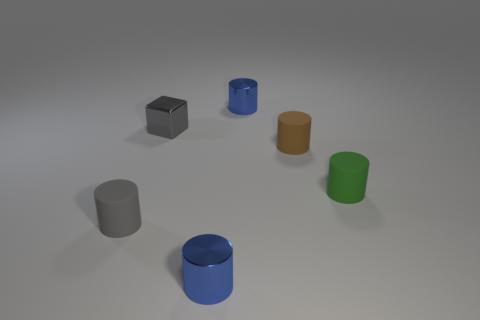Is there any other thing that has the same shape as the gray metal object?
Give a very brief answer. No. The matte cylinder that is the same color as the block is what size?
Make the answer very short. Small. What is the material of the blue cylinder that is in front of the tiny green object?
Your answer should be compact. Metal. Is the number of small metallic objects to the left of the small gray matte cylinder the same as the number of blue metallic cylinders behind the gray metal block?
Your response must be concise. No. What number of matte objects have the same color as the metallic cube?
Keep it short and to the point. 1. There is a small thing that is the same color as the shiny block; what is its material?
Offer a terse response. Rubber. Are there more tiny things that are on the left side of the block than big red rubber things?
Ensure brevity in your answer.  Yes. Do the small brown matte object and the green object have the same shape?
Offer a terse response. Yes. How many brown cylinders are the same material as the green object?
Your response must be concise. 1. What is the shape of the small metal thing in front of the green object that is behind the blue metallic cylinder in front of the gray metallic object?
Your answer should be very brief. Cylinder. 